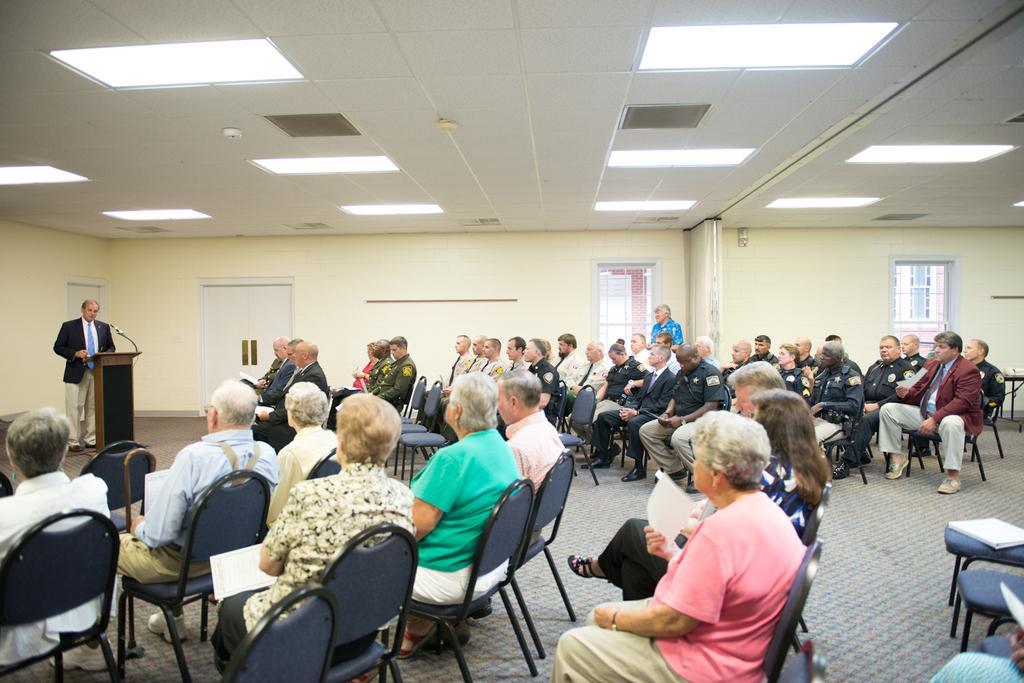In one or two sentences, can you explain what this image depicts? This image is clicked in a meeting. On the left there is a podium in front of that there is a man he wear suit, trouser and tie i think he is speaking some thing. In the middle there are many people sitting on the chairs and staring at podium. In the background there is a door, wall, window and table. At the top there is a light. 